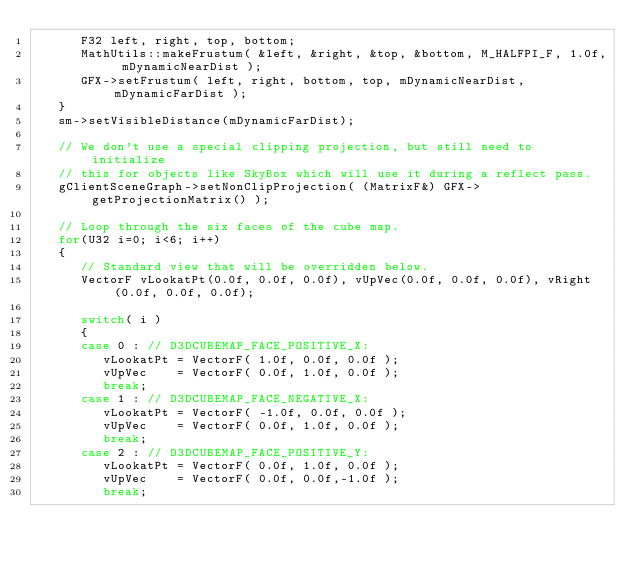Convert code to text. <code><loc_0><loc_0><loc_500><loc_500><_C++_>      F32 left, right, top, bottom;
      MathUtils::makeFrustum( &left, &right, &top, &bottom, M_HALFPI_F, 1.0f, mDynamicNearDist );
      GFX->setFrustum( left, right, bottom, top, mDynamicNearDist, mDynamicFarDist );
   }
   sm->setVisibleDistance(mDynamicFarDist);

   // We don't use a special clipping projection, but still need to initialize 
   // this for objects like SkyBox which will use it during a reflect pass.
   gClientSceneGraph->setNonClipProjection( (MatrixF&) GFX->getProjectionMatrix() );

   // Loop through the six faces of the cube map.
   for(U32 i=0; i<6; i++)
   {      
      // Standard view that will be overridden below.
      VectorF vLookatPt(0.0f, 0.0f, 0.0f), vUpVec(0.0f, 0.0f, 0.0f), vRight(0.0f, 0.0f, 0.0f);

      switch( i )
      {
      case 0 : // D3DCUBEMAP_FACE_POSITIVE_X:
         vLookatPt = VectorF( 1.0f, 0.0f, 0.0f );
         vUpVec    = VectorF( 0.0f, 1.0f, 0.0f );
         break;
      case 1 : // D3DCUBEMAP_FACE_NEGATIVE_X:
         vLookatPt = VectorF( -1.0f, 0.0f, 0.0f );
         vUpVec    = VectorF( 0.0f, 1.0f, 0.0f );
         break;
      case 2 : // D3DCUBEMAP_FACE_POSITIVE_Y:
         vLookatPt = VectorF( 0.0f, 1.0f, 0.0f );
         vUpVec    = VectorF( 0.0f, 0.0f,-1.0f );
         break;</code> 